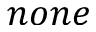Convert formula to latex. <formula><loc_0><loc_0><loc_500><loc_500>n o n e</formula> 